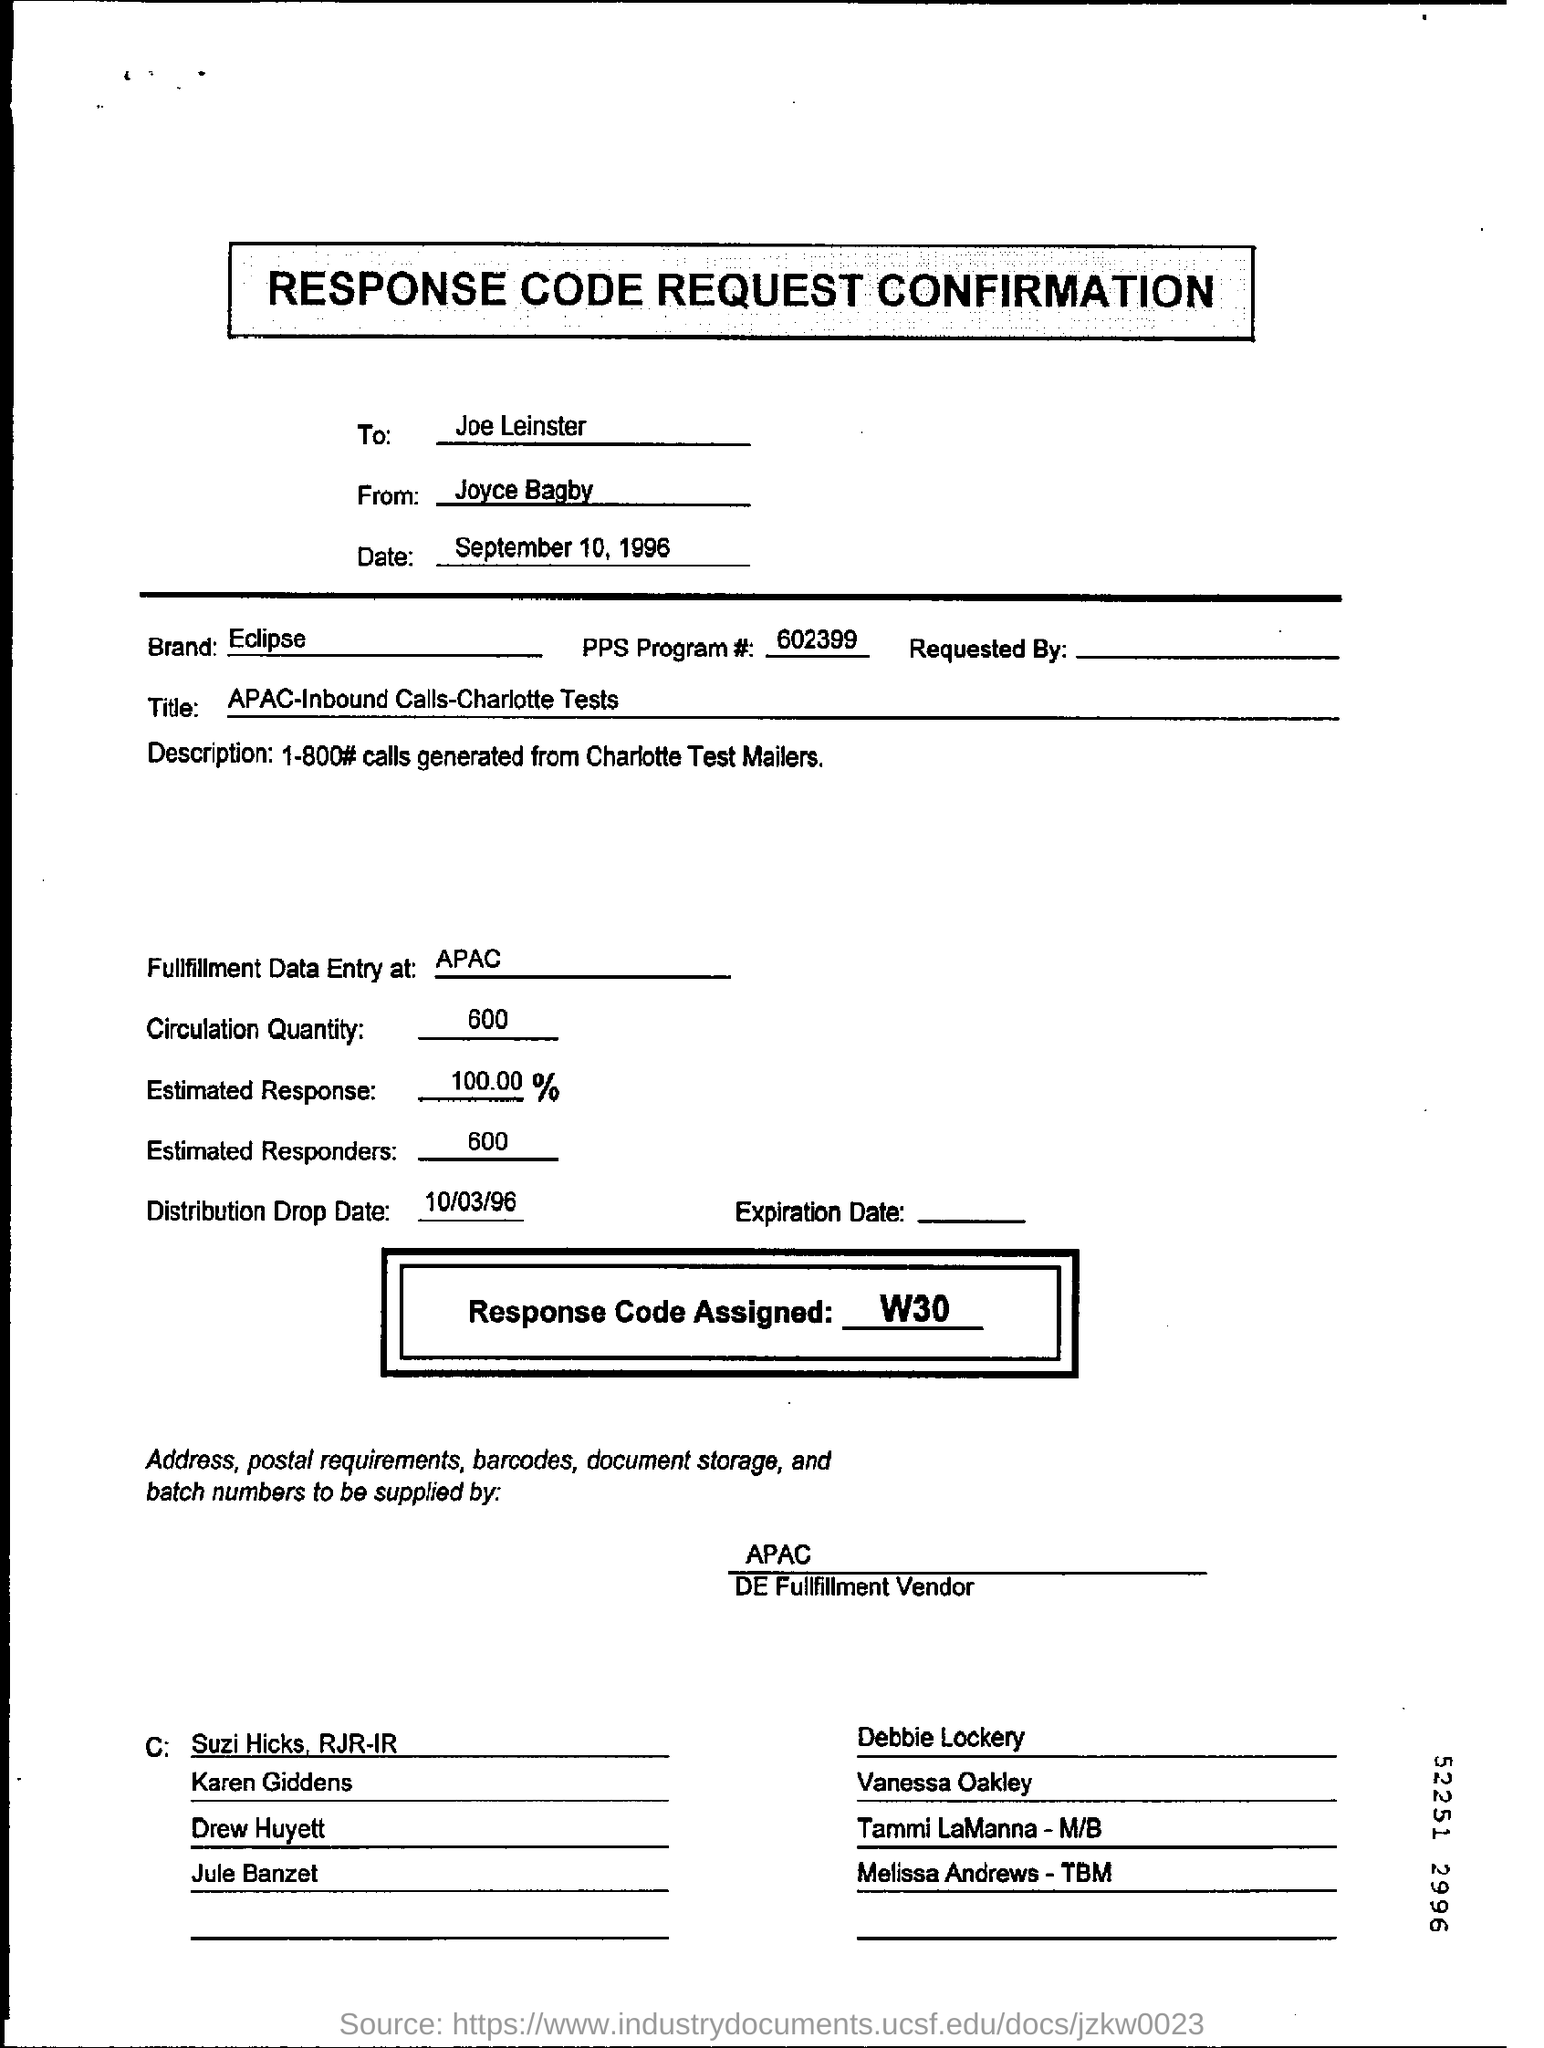Who is the sender of the Response Code Request Confirmation?
Keep it short and to the point. Joyce Bagby. What is the Circulation Quantity as per the document?
Keep it short and to the point. 600. What is the PPS Program # no?
Offer a very short reply. 602399. What is the Estimated response percentage mentioned in the document?
Offer a terse response. 100.00%. What is the Response Code Assigned?
Make the answer very short. W30. How many Estimated Responders are there as per the document?
Your response must be concise. 600. What is the Distribution Drop Date mentioned in the document?
Provide a succinct answer. 10/03/96. 